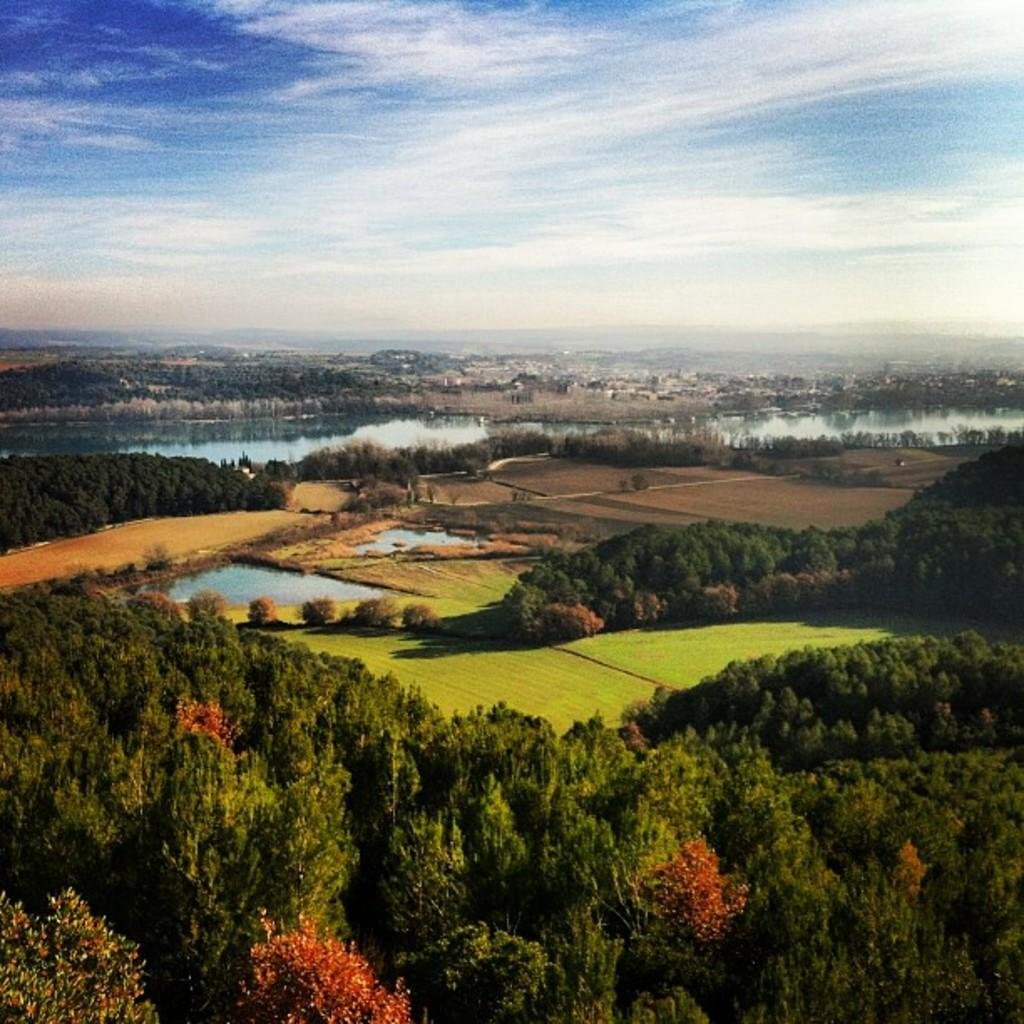What type of vegetation is present in the image? There are trees in the image. What else can be seen on the ground in the image? There is grass in the image. What natural element is visible in the image besides vegetation? There is water visible in the image. How would you describe the color of the sky in the image? The sky is blue and white in color. Can you see any crayons being used to color the trees in the image? There are no crayons present in the image, and the trees are not being colored. 